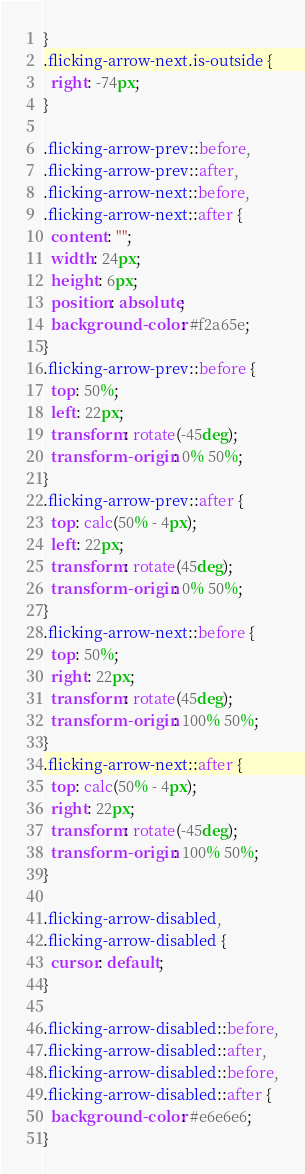<code> <loc_0><loc_0><loc_500><loc_500><_CSS_>}
.flicking-arrow-next.is-outside {
  right: -74px;
}

.flicking-arrow-prev::before,
.flicking-arrow-prev::after,
.flicking-arrow-next::before,
.flicking-arrow-next::after {
  content: "";
  width: 24px;
  height: 6px;
  position: absolute;
  background-color: #f2a65e;
}
.flicking-arrow-prev::before {
  top: 50%;
  left: 22px;
  transform: rotate(-45deg);
  transform-origin: 0% 50%;
}
.flicking-arrow-prev::after {
  top: calc(50% - 4px);
  left: 22px;
  transform: rotate(45deg);
  transform-origin: 0% 50%;
}
.flicking-arrow-next::before {
  top: 50%;
  right: 22px;
  transform: rotate(45deg);
  transform-origin: 100% 50%;
}
.flicking-arrow-next::after {
  top: calc(50% - 4px);
  right: 22px;
  transform: rotate(-45deg);
  transform-origin: 100% 50%;
}

.flicking-arrow-disabled,
.flicking-arrow-disabled {
  cursor: default;
}

.flicking-arrow-disabled::before,
.flicking-arrow-disabled::after,
.flicking-arrow-disabled::before,
.flicking-arrow-disabled::after {
  background-color: #e6e6e6;
}
</code> 